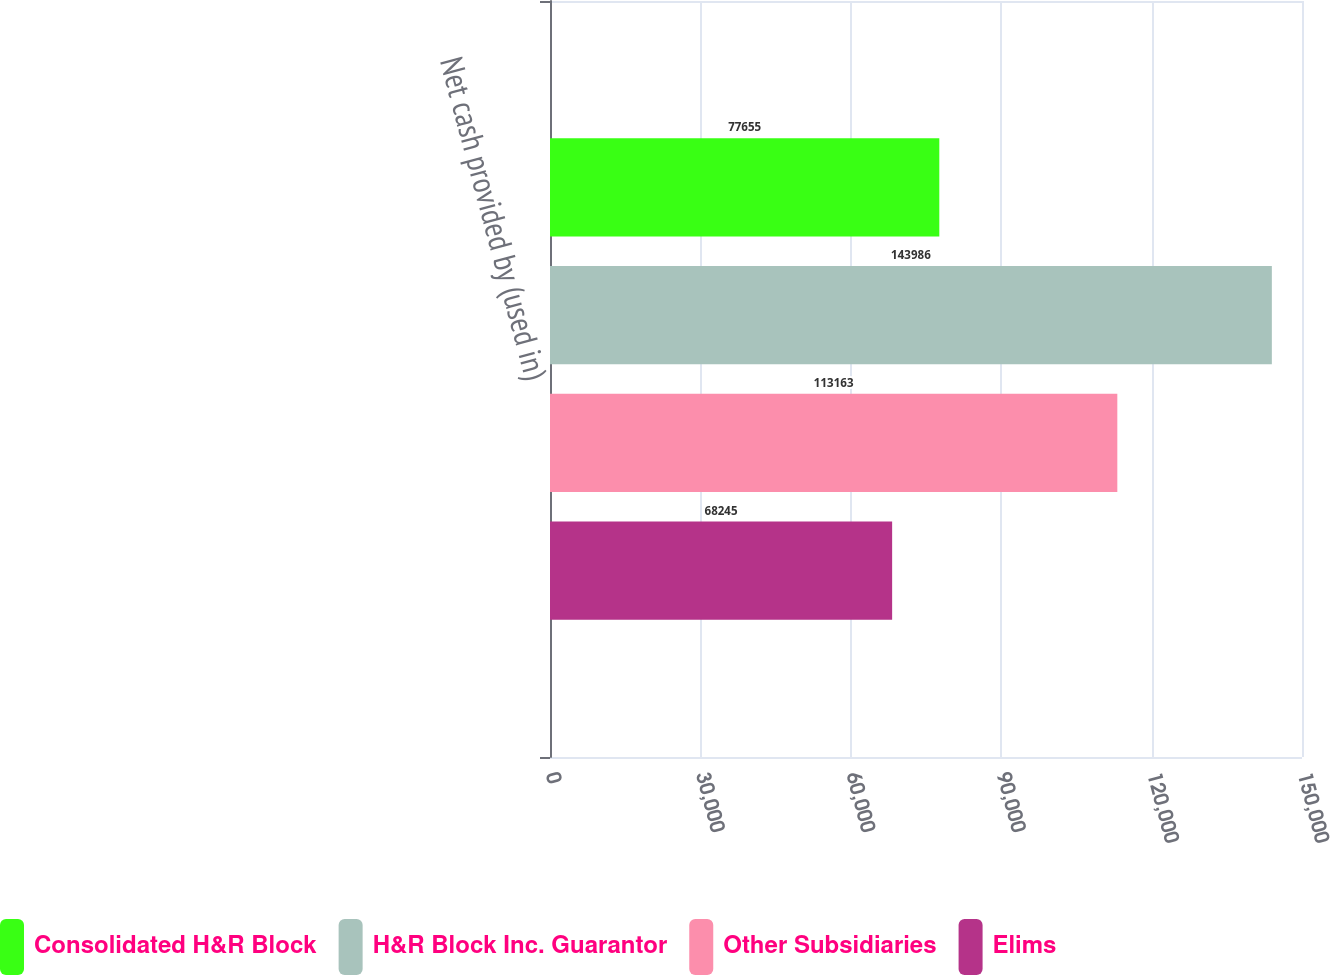Convert chart to OTSL. <chart><loc_0><loc_0><loc_500><loc_500><stacked_bar_chart><ecel><fcel>Net cash provided by (used in)<nl><fcel>Consolidated H&R Block<fcel>77655<nl><fcel>H&R Block Inc. Guarantor<fcel>143986<nl><fcel>Other Subsidiaries<fcel>113163<nl><fcel>Elims<fcel>68245<nl></chart> 